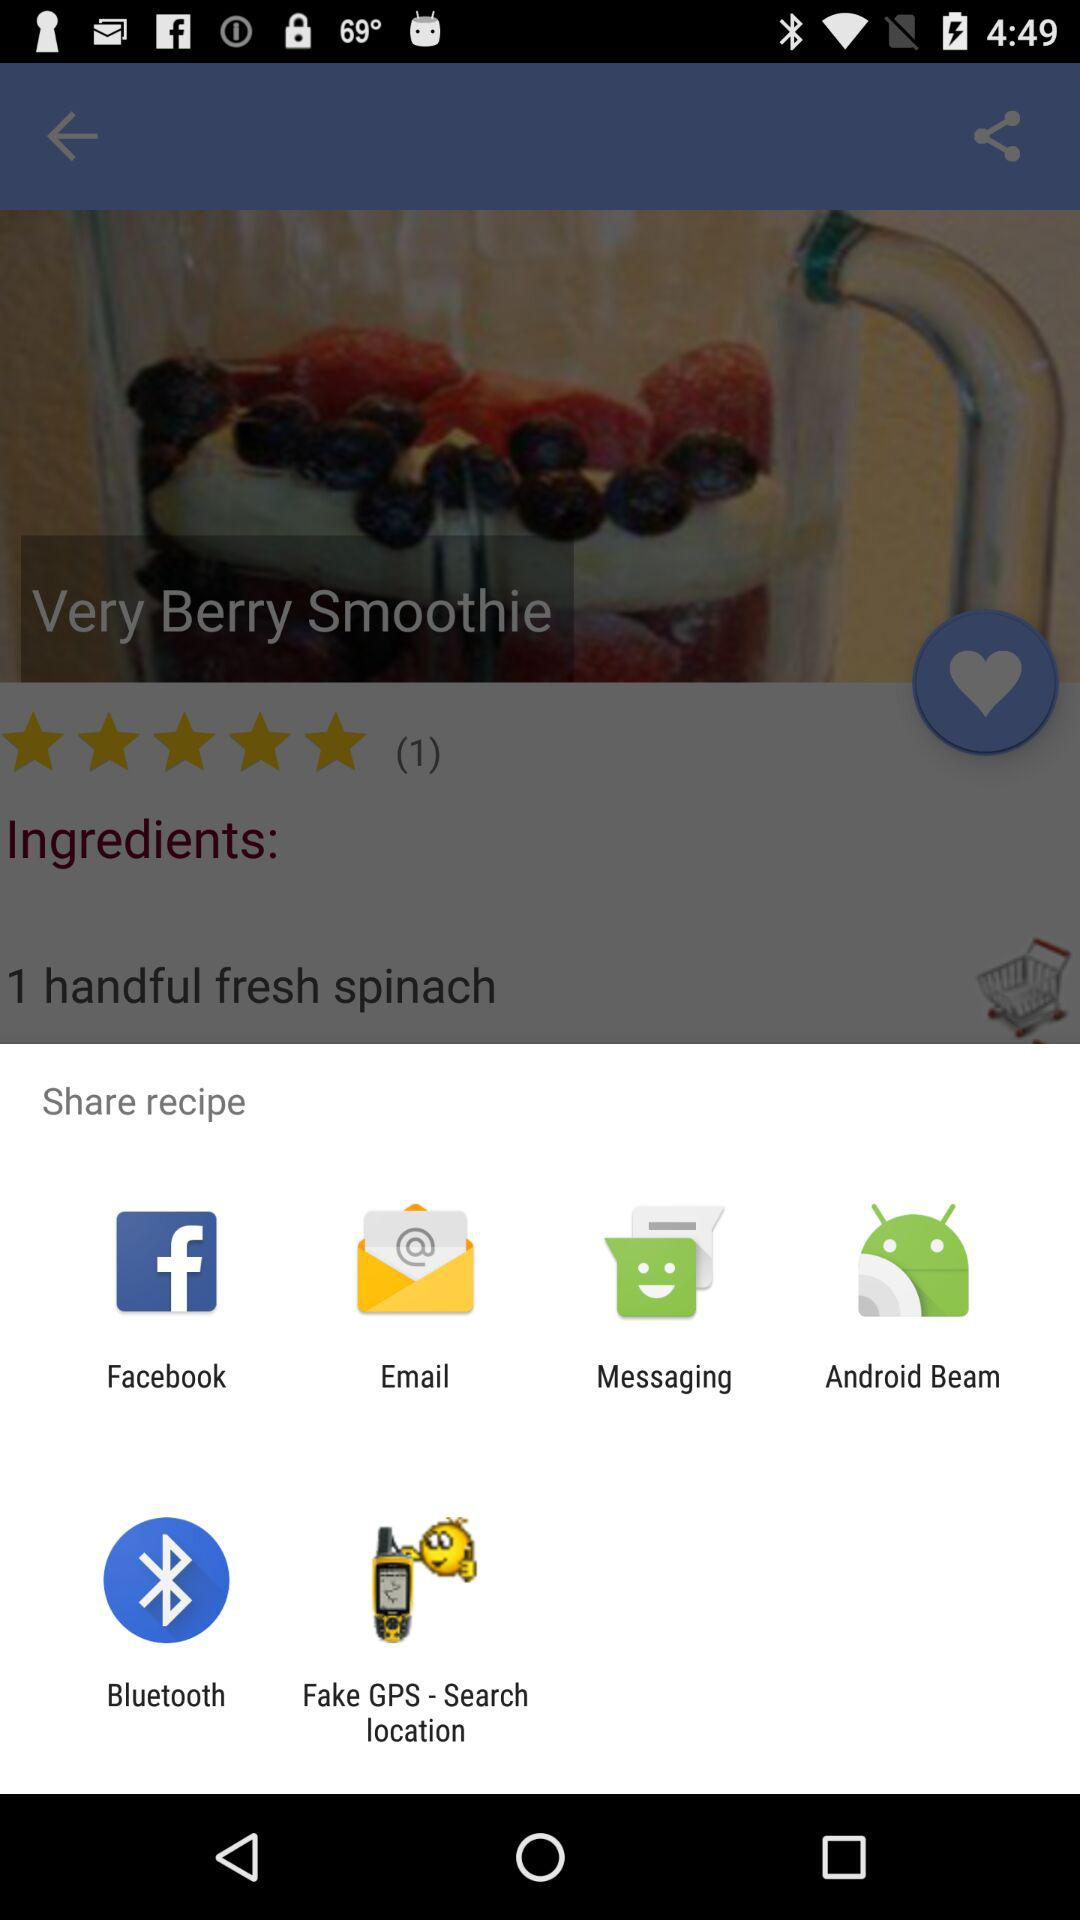Through which application can the recipe be shared? The recipe can be shared through "Facebook", "Email", "Messaging", "Android Beam", "Bluetooth" and "Fake GPS - Search location". 